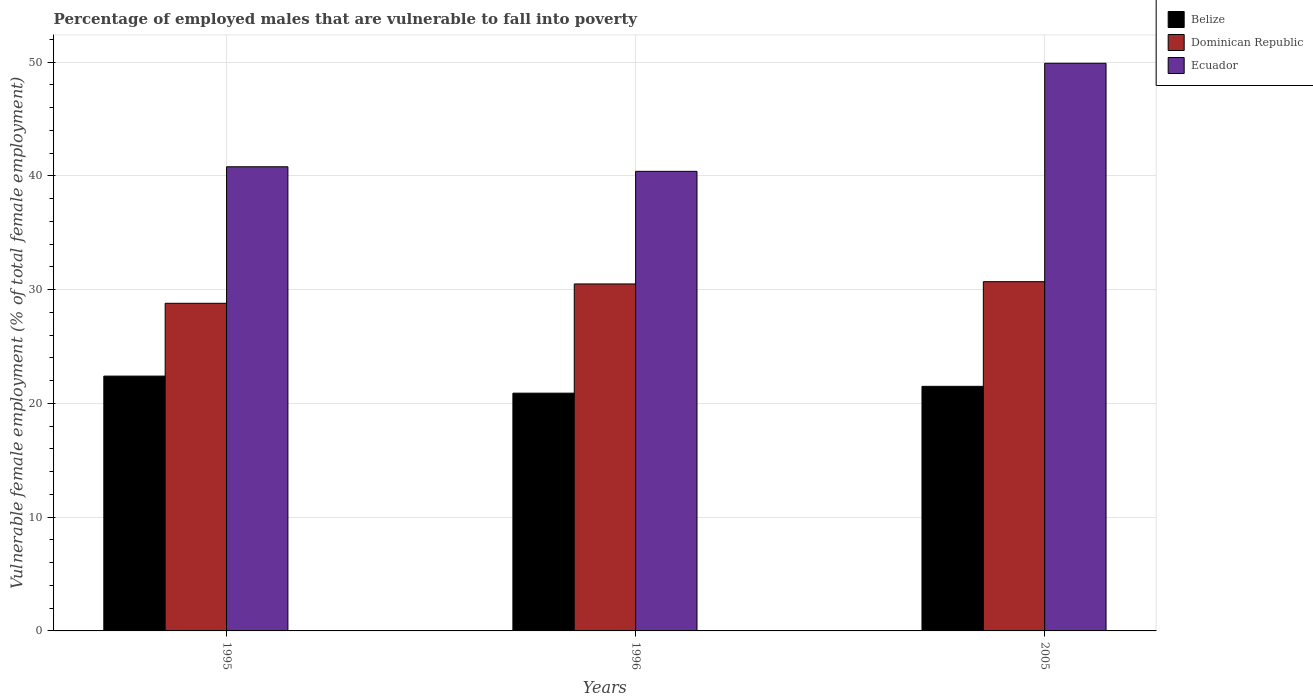How many different coloured bars are there?
Keep it short and to the point. 3. How many groups of bars are there?
Provide a succinct answer. 3. Are the number of bars per tick equal to the number of legend labels?
Your response must be concise. Yes. Are the number of bars on each tick of the X-axis equal?
Offer a very short reply. Yes. What is the percentage of employed males who are vulnerable to fall into poverty in Ecuador in 2005?
Your response must be concise. 49.9. Across all years, what is the maximum percentage of employed males who are vulnerable to fall into poverty in Dominican Republic?
Provide a short and direct response. 30.7. Across all years, what is the minimum percentage of employed males who are vulnerable to fall into poverty in Dominican Republic?
Keep it short and to the point. 28.8. In which year was the percentage of employed males who are vulnerable to fall into poverty in Dominican Republic maximum?
Provide a short and direct response. 2005. In which year was the percentage of employed males who are vulnerable to fall into poverty in Belize minimum?
Make the answer very short. 1996. What is the total percentage of employed males who are vulnerable to fall into poverty in Dominican Republic in the graph?
Ensure brevity in your answer.  90. What is the difference between the percentage of employed males who are vulnerable to fall into poverty in Belize in 1996 and that in 2005?
Offer a terse response. -0.6. What is the difference between the percentage of employed males who are vulnerable to fall into poverty in Dominican Republic in 2005 and the percentage of employed males who are vulnerable to fall into poverty in Ecuador in 1996?
Your answer should be very brief. -9.7. In the year 1996, what is the difference between the percentage of employed males who are vulnerable to fall into poverty in Ecuador and percentage of employed males who are vulnerable to fall into poverty in Belize?
Ensure brevity in your answer.  19.5. In how many years, is the percentage of employed males who are vulnerable to fall into poverty in Belize greater than 28 %?
Offer a very short reply. 0. What is the ratio of the percentage of employed males who are vulnerable to fall into poverty in Belize in 1996 to that in 2005?
Keep it short and to the point. 0.97. Is the percentage of employed males who are vulnerable to fall into poverty in Belize in 1996 less than that in 2005?
Ensure brevity in your answer.  Yes. What is the difference between the highest and the second highest percentage of employed males who are vulnerable to fall into poverty in Dominican Republic?
Offer a terse response. 0.2. What is the difference between the highest and the lowest percentage of employed males who are vulnerable to fall into poverty in Belize?
Keep it short and to the point. 1.5. What does the 3rd bar from the left in 2005 represents?
Ensure brevity in your answer.  Ecuador. What does the 1st bar from the right in 2005 represents?
Provide a succinct answer. Ecuador. Is it the case that in every year, the sum of the percentage of employed males who are vulnerable to fall into poverty in Belize and percentage of employed males who are vulnerable to fall into poverty in Ecuador is greater than the percentage of employed males who are vulnerable to fall into poverty in Dominican Republic?
Your response must be concise. Yes. How many years are there in the graph?
Keep it short and to the point. 3. What is the difference between two consecutive major ticks on the Y-axis?
Make the answer very short. 10. Where does the legend appear in the graph?
Your response must be concise. Top right. How many legend labels are there?
Keep it short and to the point. 3. How are the legend labels stacked?
Your answer should be compact. Vertical. What is the title of the graph?
Provide a succinct answer. Percentage of employed males that are vulnerable to fall into poverty. Does "Uzbekistan" appear as one of the legend labels in the graph?
Your response must be concise. No. What is the label or title of the Y-axis?
Make the answer very short. Vulnerable female employment (% of total female employment). What is the Vulnerable female employment (% of total female employment) in Belize in 1995?
Give a very brief answer. 22.4. What is the Vulnerable female employment (% of total female employment) of Dominican Republic in 1995?
Offer a terse response. 28.8. What is the Vulnerable female employment (% of total female employment) of Ecuador in 1995?
Keep it short and to the point. 40.8. What is the Vulnerable female employment (% of total female employment) in Belize in 1996?
Your answer should be compact. 20.9. What is the Vulnerable female employment (% of total female employment) of Dominican Republic in 1996?
Offer a very short reply. 30.5. What is the Vulnerable female employment (% of total female employment) of Ecuador in 1996?
Ensure brevity in your answer.  40.4. What is the Vulnerable female employment (% of total female employment) in Dominican Republic in 2005?
Offer a terse response. 30.7. What is the Vulnerable female employment (% of total female employment) in Ecuador in 2005?
Keep it short and to the point. 49.9. Across all years, what is the maximum Vulnerable female employment (% of total female employment) of Belize?
Provide a short and direct response. 22.4. Across all years, what is the maximum Vulnerable female employment (% of total female employment) of Dominican Republic?
Give a very brief answer. 30.7. Across all years, what is the maximum Vulnerable female employment (% of total female employment) of Ecuador?
Keep it short and to the point. 49.9. Across all years, what is the minimum Vulnerable female employment (% of total female employment) of Belize?
Provide a succinct answer. 20.9. Across all years, what is the minimum Vulnerable female employment (% of total female employment) of Dominican Republic?
Ensure brevity in your answer.  28.8. Across all years, what is the minimum Vulnerable female employment (% of total female employment) in Ecuador?
Your answer should be compact. 40.4. What is the total Vulnerable female employment (% of total female employment) of Belize in the graph?
Your answer should be compact. 64.8. What is the total Vulnerable female employment (% of total female employment) of Dominican Republic in the graph?
Your answer should be compact. 90. What is the total Vulnerable female employment (% of total female employment) of Ecuador in the graph?
Give a very brief answer. 131.1. What is the difference between the Vulnerable female employment (% of total female employment) of Belize in 1995 and that in 1996?
Ensure brevity in your answer.  1.5. What is the difference between the Vulnerable female employment (% of total female employment) of Ecuador in 1995 and that in 1996?
Your answer should be very brief. 0.4. What is the difference between the Vulnerable female employment (% of total female employment) in Dominican Republic in 1995 and that in 2005?
Provide a short and direct response. -1.9. What is the difference between the Vulnerable female employment (% of total female employment) in Ecuador in 1995 and that in 2005?
Your answer should be compact. -9.1. What is the difference between the Vulnerable female employment (% of total female employment) in Belize in 1996 and that in 2005?
Offer a terse response. -0.6. What is the difference between the Vulnerable female employment (% of total female employment) of Ecuador in 1996 and that in 2005?
Offer a very short reply. -9.5. What is the difference between the Vulnerable female employment (% of total female employment) in Belize in 1995 and the Vulnerable female employment (% of total female employment) in Ecuador in 1996?
Make the answer very short. -18. What is the difference between the Vulnerable female employment (% of total female employment) in Belize in 1995 and the Vulnerable female employment (% of total female employment) in Dominican Republic in 2005?
Keep it short and to the point. -8.3. What is the difference between the Vulnerable female employment (% of total female employment) of Belize in 1995 and the Vulnerable female employment (% of total female employment) of Ecuador in 2005?
Provide a succinct answer. -27.5. What is the difference between the Vulnerable female employment (% of total female employment) of Dominican Republic in 1995 and the Vulnerable female employment (% of total female employment) of Ecuador in 2005?
Make the answer very short. -21.1. What is the difference between the Vulnerable female employment (% of total female employment) of Belize in 1996 and the Vulnerable female employment (% of total female employment) of Dominican Republic in 2005?
Provide a succinct answer. -9.8. What is the difference between the Vulnerable female employment (% of total female employment) of Belize in 1996 and the Vulnerable female employment (% of total female employment) of Ecuador in 2005?
Make the answer very short. -29. What is the difference between the Vulnerable female employment (% of total female employment) in Dominican Republic in 1996 and the Vulnerable female employment (% of total female employment) in Ecuador in 2005?
Provide a short and direct response. -19.4. What is the average Vulnerable female employment (% of total female employment) in Belize per year?
Make the answer very short. 21.6. What is the average Vulnerable female employment (% of total female employment) in Dominican Republic per year?
Ensure brevity in your answer.  30. What is the average Vulnerable female employment (% of total female employment) in Ecuador per year?
Offer a terse response. 43.7. In the year 1995, what is the difference between the Vulnerable female employment (% of total female employment) in Belize and Vulnerable female employment (% of total female employment) in Ecuador?
Give a very brief answer. -18.4. In the year 1996, what is the difference between the Vulnerable female employment (% of total female employment) of Belize and Vulnerable female employment (% of total female employment) of Ecuador?
Give a very brief answer. -19.5. In the year 2005, what is the difference between the Vulnerable female employment (% of total female employment) in Belize and Vulnerable female employment (% of total female employment) in Dominican Republic?
Offer a terse response. -9.2. In the year 2005, what is the difference between the Vulnerable female employment (% of total female employment) of Belize and Vulnerable female employment (% of total female employment) of Ecuador?
Offer a terse response. -28.4. In the year 2005, what is the difference between the Vulnerable female employment (% of total female employment) in Dominican Republic and Vulnerable female employment (% of total female employment) in Ecuador?
Your response must be concise. -19.2. What is the ratio of the Vulnerable female employment (% of total female employment) in Belize in 1995 to that in 1996?
Keep it short and to the point. 1.07. What is the ratio of the Vulnerable female employment (% of total female employment) of Dominican Republic in 1995 to that in 1996?
Your answer should be very brief. 0.94. What is the ratio of the Vulnerable female employment (% of total female employment) in Ecuador in 1995 to that in 1996?
Keep it short and to the point. 1.01. What is the ratio of the Vulnerable female employment (% of total female employment) of Belize in 1995 to that in 2005?
Your response must be concise. 1.04. What is the ratio of the Vulnerable female employment (% of total female employment) in Dominican Republic in 1995 to that in 2005?
Your answer should be compact. 0.94. What is the ratio of the Vulnerable female employment (% of total female employment) in Ecuador in 1995 to that in 2005?
Provide a succinct answer. 0.82. What is the ratio of the Vulnerable female employment (% of total female employment) of Belize in 1996 to that in 2005?
Ensure brevity in your answer.  0.97. What is the ratio of the Vulnerable female employment (% of total female employment) in Ecuador in 1996 to that in 2005?
Your response must be concise. 0.81. What is the difference between the highest and the second highest Vulnerable female employment (% of total female employment) in Belize?
Ensure brevity in your answer.  0.9. What is the difference between the highest and the lowest Vulnerable female employment (% of total female employment) in Belize?
Your answer should be very brief. 1.5. What is the difference between the highest and the lowest Vulnerable female employment (% of total female employment) of Dominican Republic?
Offer a terse response. 1.9. 